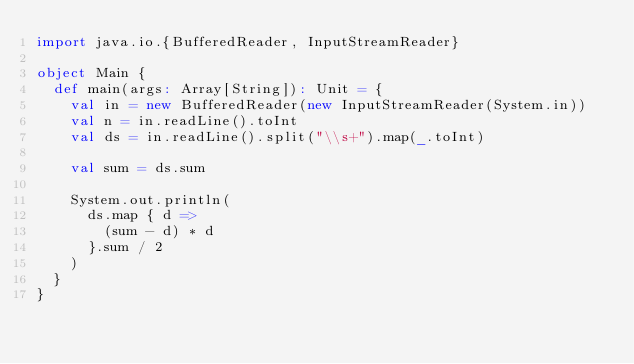Convert code to text. <code><loc_0><loc_0><loc_500><loc_500><_Scala_>import java.io.{BufferedReader, InputStreamReader}

object Main {
  def main(args: Array[String]): Unit = {
    val in = new BufferedReader(new InputStreamReader(System.in))
    val n = in.readLine().toInt
    val ds = in.readLine().split("\\s+").map(_.toInt)

    val sum = ds.sum

    System.out.println(
      ds.map { d =>
        (sum - d) * d
      }.sum / 2
    )
  }
}
</code> 